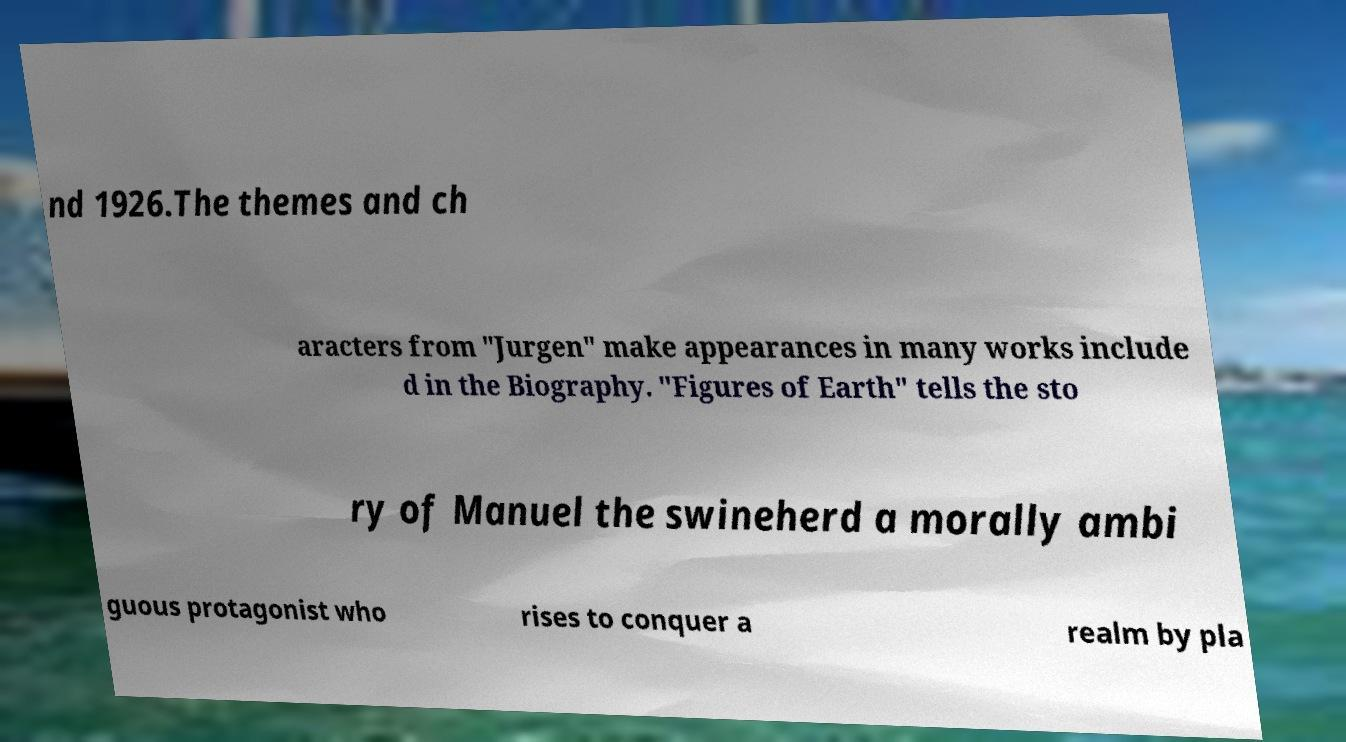Please read and relay the text visible in this image. What does it say? nd 1926.The themes and ch aracters from "Jurgen" make appearances in many works include d in the Biography. "Figures of Earth" tells the sto ry of Manuel the swineherd a morally ambi guous protagonist who rises to conquer a realm by pla 